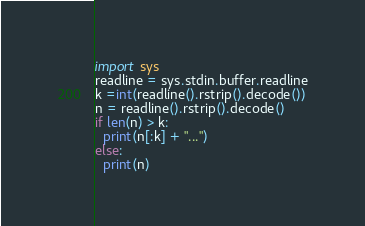<code> <loc_0><loc_0><loc_500><loc_500><_Python_>import sys
readline = sys.stdin.buffer.readline
k =int(readline().rstrip().decode())
n = readline().rstrip().decode()
if len(n) > k:
  print(n[:k] + "...")
else:
  print(n)
</code> 